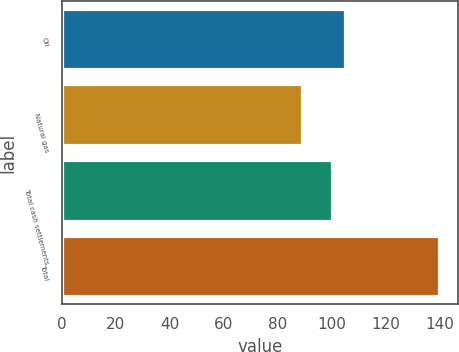Convert chart to OTSL. <chart><loc_0><loc_0><loc_500><loc_500><bar_chart><fcel>Oil<fcel>Natural gas<fcel>Total cash settlements<fcel>Total<nl><fcel>105.1<fcel>89<fcel>100<fcel>140<nl></chart> 